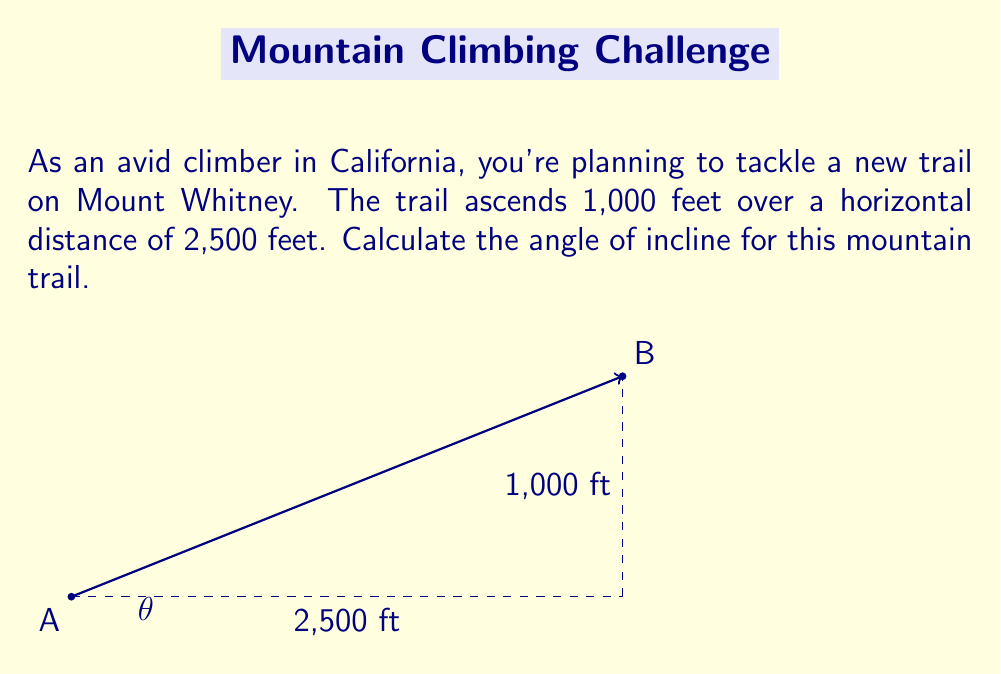Give your solution to this math problem. To calculate the angle of incline, we can use trigonometry, specifically the arctangent function. Let's approach this step-by-step:

1) First, we need to identify the right triangle formed by the trail:
   - The vertical rise is 1,000 feet (opposite side)
   - The horizontal distance is 2,500 feet (adjacent side)

2) The angle of incline, let's call it $\theta$, is the angle between the horizontal and the trail.

3) We can use the tangent function to relate these sides:

   $$\tan(\theta) = \frac{\text{opposite}}{\text{adjacent}} = \frac{\text{rise}}{\text{run}}$$

4) Substituting our values:

   $$\tan(\theta) = \frac{1000}{2500} = \frac{2}{5} = 0.4$$

5) To find $\theta$, we need to use the inverse tangent (arctangent) function:

   $$\theta = \arctan(0.4)$$

6) Using a calculator or computational tool:

   $$\theta \approx 21.8014^\circ$$

7) Rounding to two decimal places:

   $$\theta \approx 21.80^\circ$$

Thus, the angle of incline for the trail is approximately 21.80 degrees.
Answer: $21.80^\circ$ 